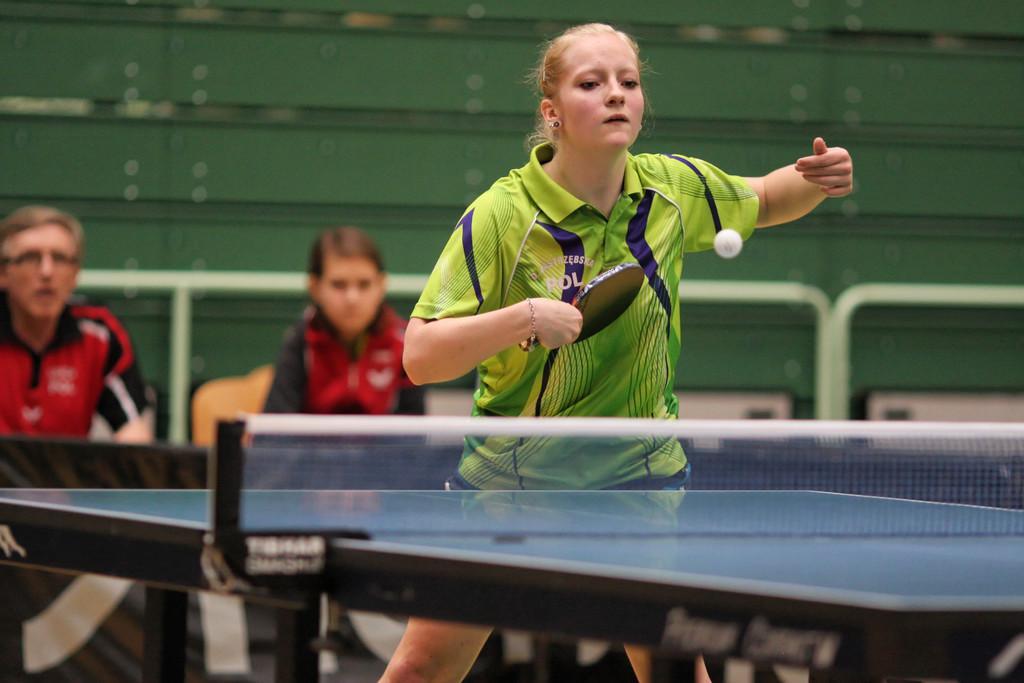Please provide a concise description of this image. In the image there is a woman wearing a green jersey playing table tennis and back side there is woman and man say, It seems to be of play area for table tennis. 